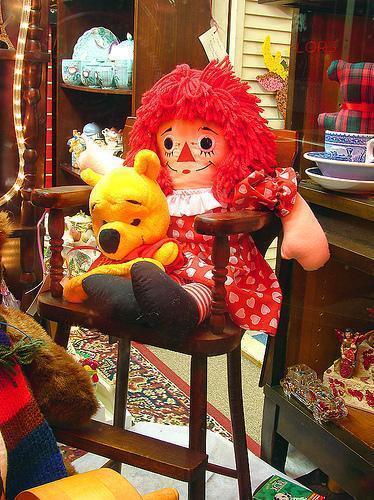What iconic child favorite is there besides Winnie the Pooh?
Choose the correct response and explain in the format: 'Answer: answer
Rationale: rationale.'
Options: Raggedy andy, tigger, raggedy ann, chatty cathy. Answer: raggedy ann.
Rationale: There is raggedy ann sitting next to winnie the pooh. 